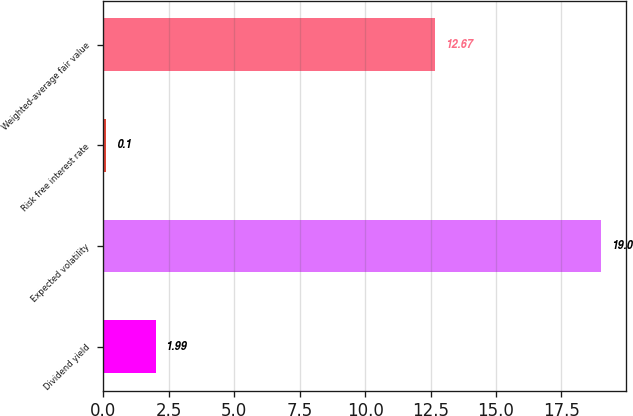<chart> <loc_0><loc_0><loc_500><loc_500><bar_chart><fcel>Dividend yield<fcel>Expected volatility<fcel>Risk free interest rate<fcel>Weighted-average fair value<nl><fcel>1.99<fcel>19<fcel>0.1<fcel>12.67<nl></chart> 